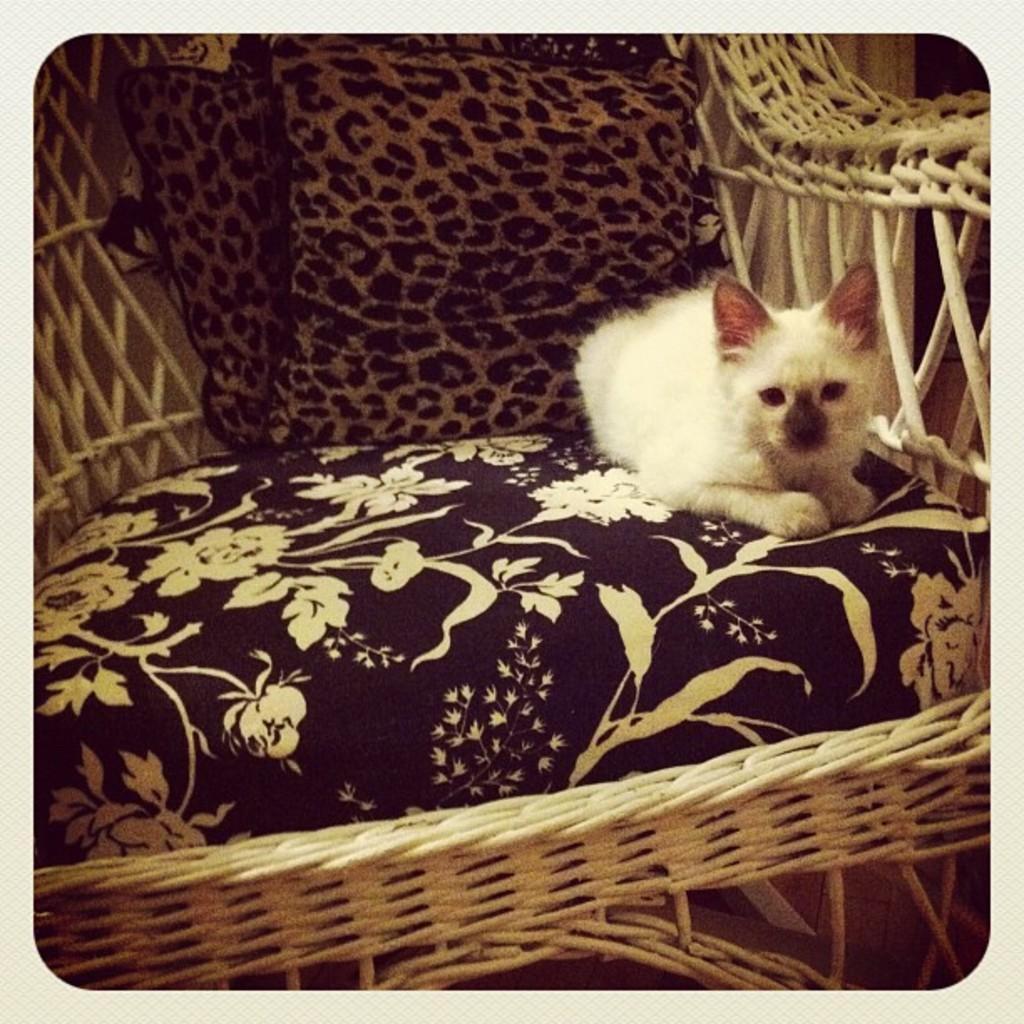Could you give a brief overview of what you see in this image? In this image I can see a white color animal is sitting on the sofa chair. 